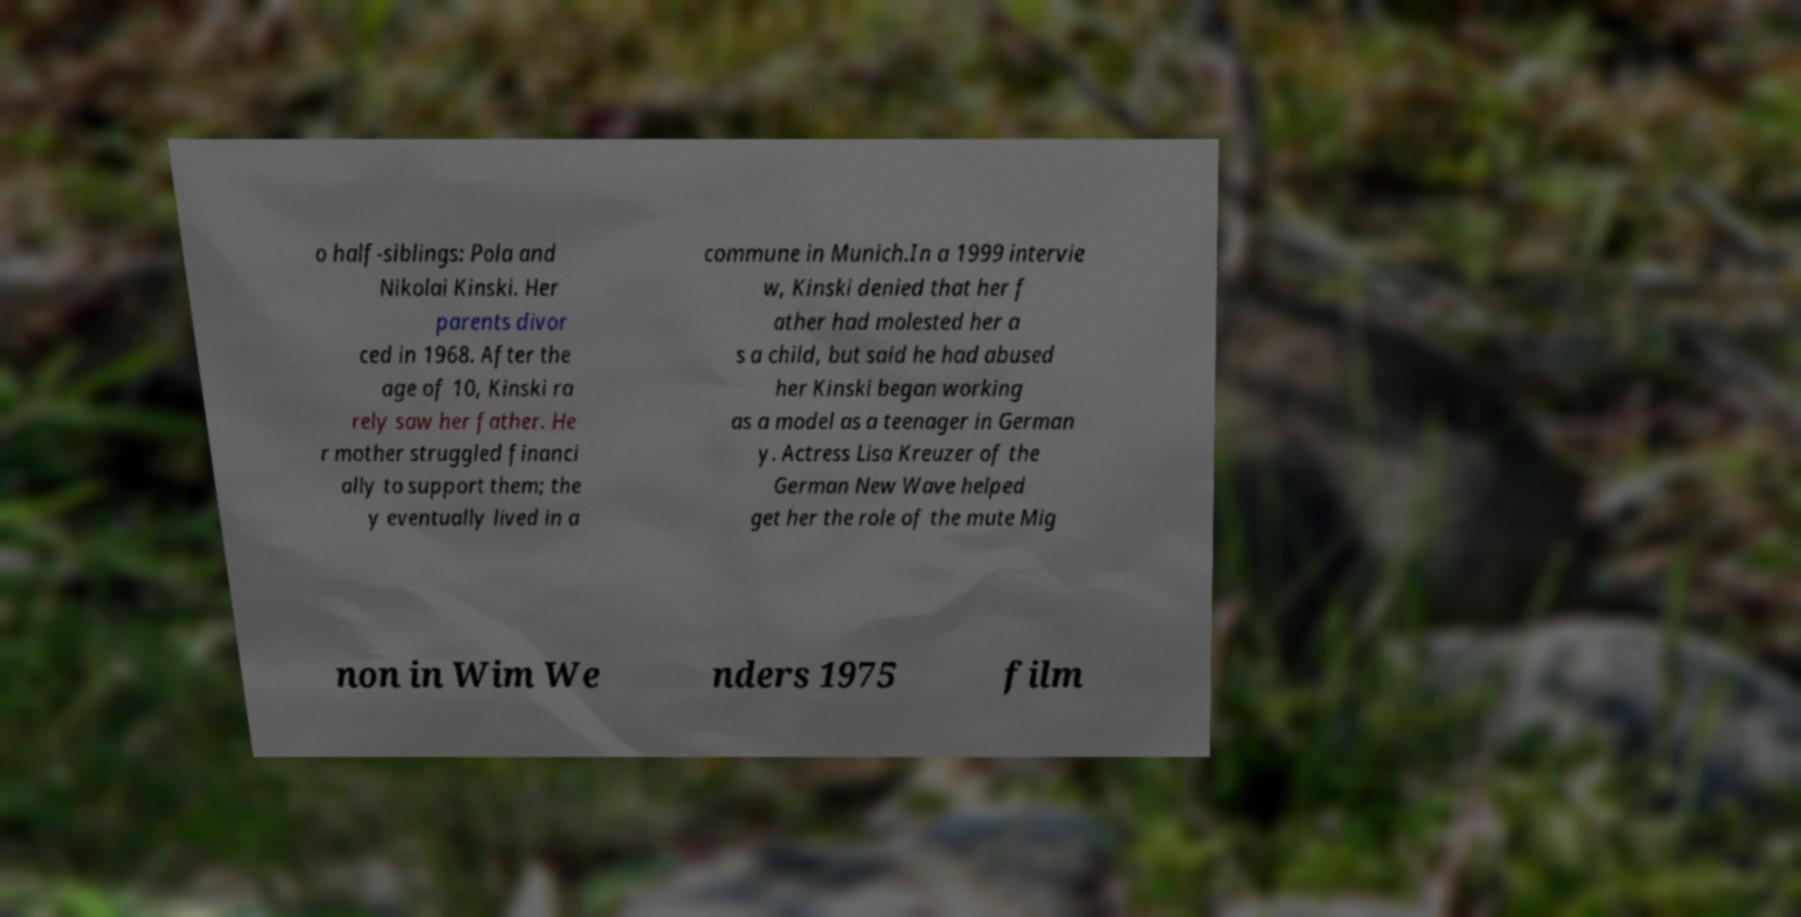I need the written content from this picture converted into text. Can you do that? o half-siblings: Pola and Nikolai Kinski. Her parents divor ced in 1968. After the age of 10, Kinski ra rely saw her father. He r mother struggled financi ally to support them; the y eventually lived in a commune in Munich.In a 1999 intervie w, Kinski denied that her f ather had molested her a s a child, but said he had abused her Kinski began working as a model as a teenager in German y. Actress Lisa Kreuzer of the German New Wave helped get her the role of the mute Mig non in Wim We nders 1975 film 